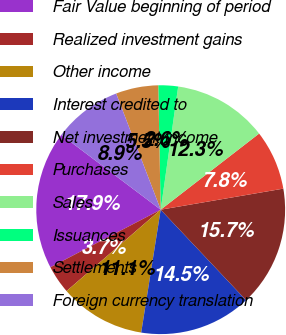<chart> <loc_0><loc_0><loc_500><loc_500><pie_chart><fcel>Fair Value beginning of period<fcel>Realized investment gains<fcel>Other income<fcel>Interest credited to<fcel>Net investment income<fcel>Purchases<fcel>Sales<fcel>Issuances<fcel>Settlements<fcel>Foreign currency translation<nl><fcel>17.93%<fcel>3.69%<fcel>11.15%<fcel>14.54%<fcel>15.67%<fcel>7.77%<fcel>12.28%<fcel>2.56%<fcel>5.51%<fcel>8.9%<nl></chart> 